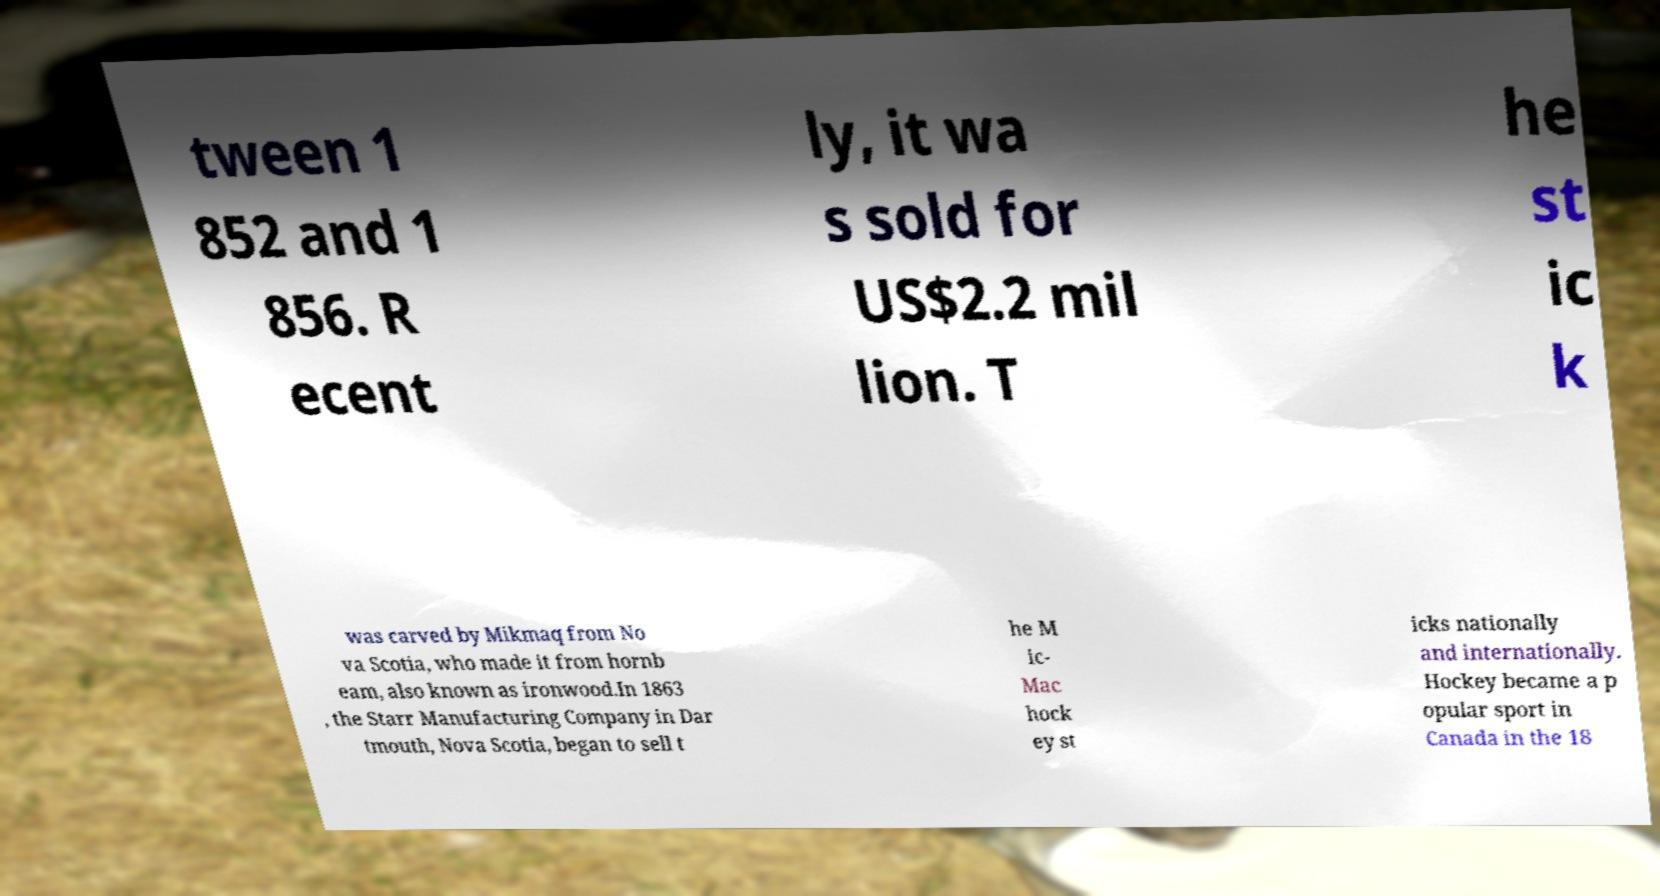There's text embedded in this image that I need extracted. Can you transcribe it verbatim? tween 1 852 and 1 856. R ecent ly, it wa s sold for US$2.2 mil lion. T he st ic k was carved by Mikmaq from No va Scotia, who made it from hornb eam, also known as ironwood.In 1863 , the Starr Manufacturing Company in Dar tmouth, Nova Scotia, began to sell t he M ic- Mac hock ey st icks nationally and internationally. Hockey became a p opular sport in Canada in the 18 